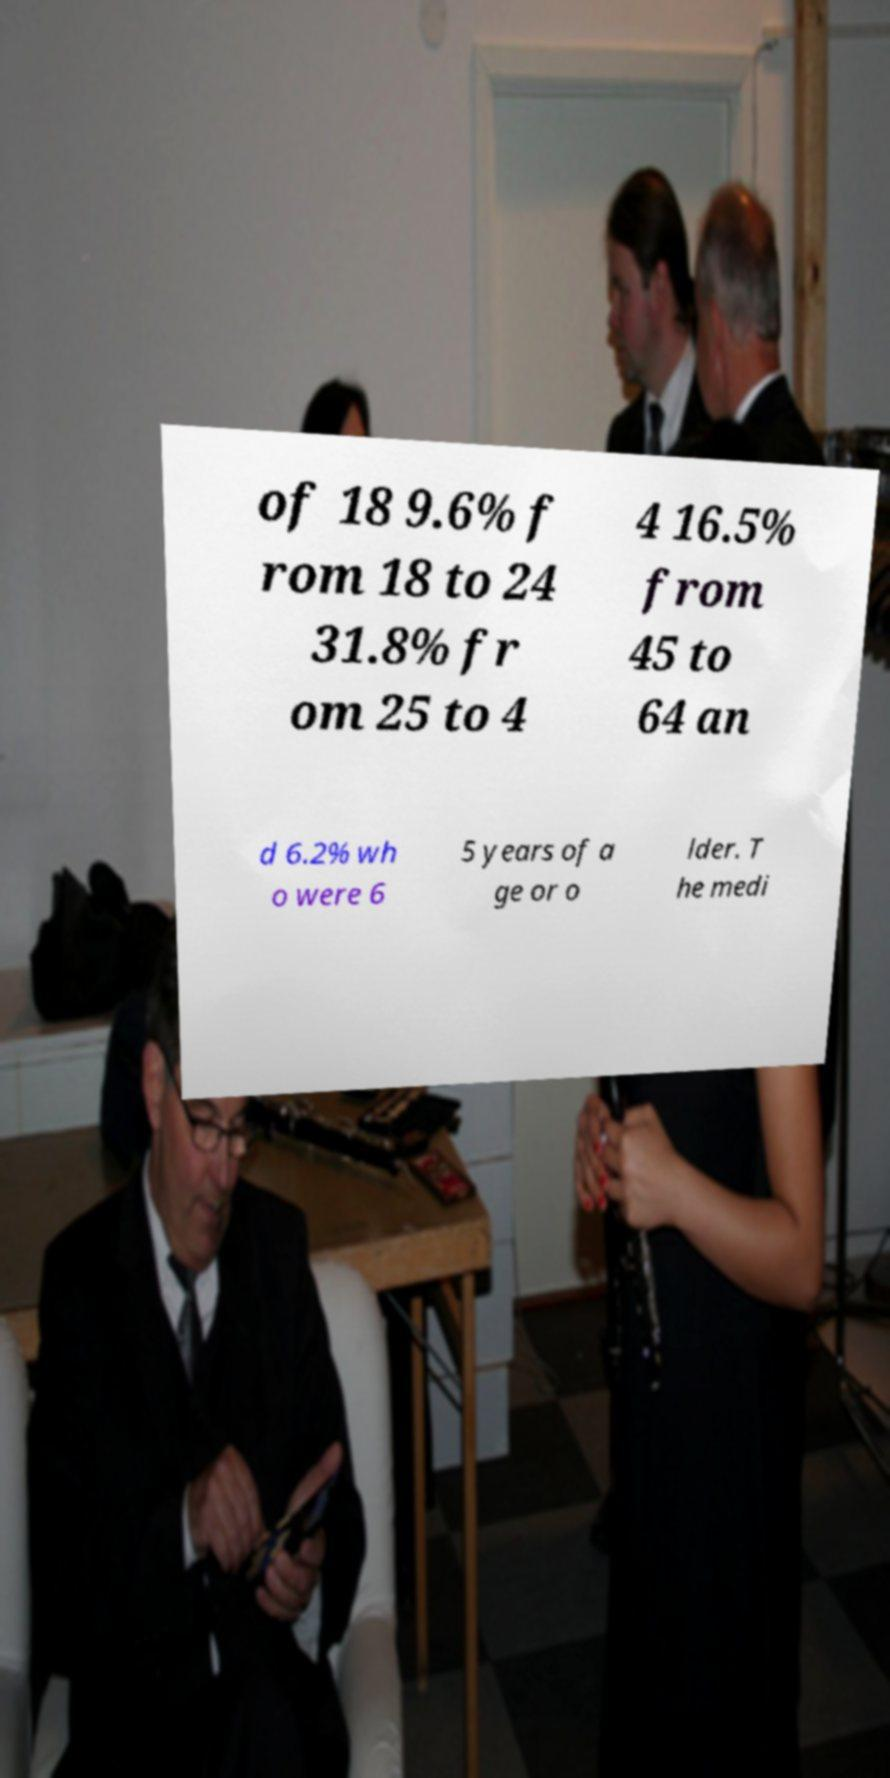What messages or text are displayed in this image? I need them in a readable, typed format. of 18 9.6% f rom 18 to 24 31.8% fr om 25 to 4 4 16.5% from 45 to 64 an d 6.2% wh o were 6 5 years of a ge or o lder. T he medi 